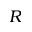<formula> <loc_0><loc_0><loc_500><loc_500>R</formula> 